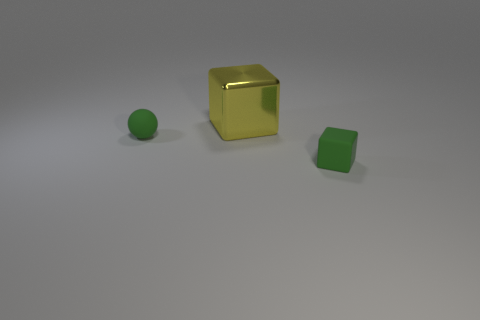What is the size of the green rubber thing that is the same shape as the big yellow thing?
Keep it short and to the point. Small. There is a object that is to the left of the block that is on the left side of the block that is to the right of the yellow metallic object; what is its material?
Provide a succinct answer. Rubber. Are any small gray shiny objects visible?
Your response must be concise. No. Is the color of the sphere the same as the tiny matte object right of the yellow shiny cube?
Keep it short and to the point. Yes. What is the color of the small sphere?
Your response must be concise. Green. Is there any other thing that has the same shape as the large thing?
Provide a short and direct response. Yes. The other thing that is the same shape as the big yellow thing is what color?
Keep it short and to the point. Green. How many cylinders are either large yellow shiny objects or large gray matte objects?
Ensure brevity in your answer.  0. There is a sphere that is the same material as the small green block; what is its color?
Your answer should be very brief. Green. There is a cube right of the yellow metal object; does it have the same size as the green ball?
Your answer should be very brief. Yes. 